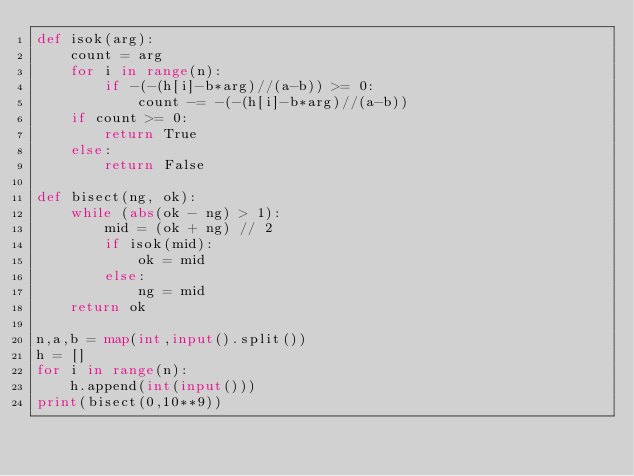<code> <loc_0><loc_0><loc_500><loc_500><_Python_>def isok(arg):
    count = arg
    for i in range(n):
        if -(-(h[i]-b*arg)//(a-b)) >= 0:
            count -= -(-(h[i]-b*arg)//(a-b))
    if count >= 0:
        return True
    else:
        return False

def bisect(ng, ok):
    while (abs(ok - ng) > 1):
        mid = (ok + ng) // 2
        if isok(mid):
            ok = mid
        else:
            ng = mid
    return ok

n,a,b = map(int,input().split())
h = []
for i in range(n):
    h.append(int(input()))
print(bisect(0,10**9))
</code> 